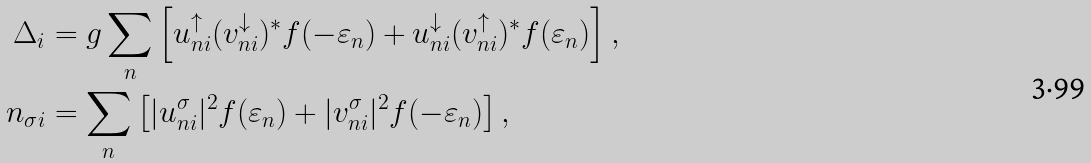<formula> <loc_0><loc_0><loc_500><loc_500>\Delta _ { i } & = g \sum _ { n } \left [ u _ { n i } ^ { \uparrow } ( v _ { n i } ^ { \downarrow } ) ^ { * } f ( - \varepsilon _ { n } ) + u _ { n i } ^ { \downarrow } ( v _ { n i } ^ { \uparrow } ) ^ { * } f ( \varepsilon _ { n } ) \right ] , \\ n _ { \sigma i } & = \sum _ { n } \left [ | u _ { n i } ^ { \sigma } | ^ { 2 } f ( \varepsilon _ { n } ) + | v _ { n i } ^ { \sigma } | ^ { 2 } f ( - \varepsilon _ { n } ) \right ] ,</formula> 